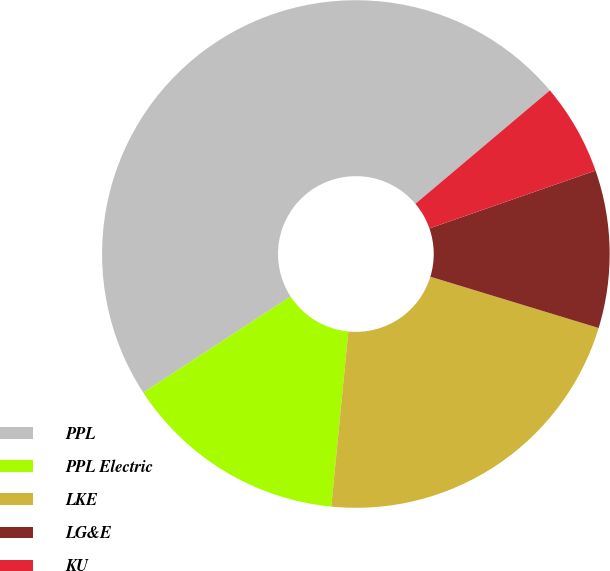Convert chart. <chart><loc_0><loc_0><loc_500><loc_500><pie_chart><fcel>PPL<fcel>PPL Electric<fcel>LKE<fcel>LG&E<fcel>KU<nl><fcel>48.03%<fcel>14.26%<fcel>21.83%<fcel>10.04%<fcel>5.82%<nl></chart> 